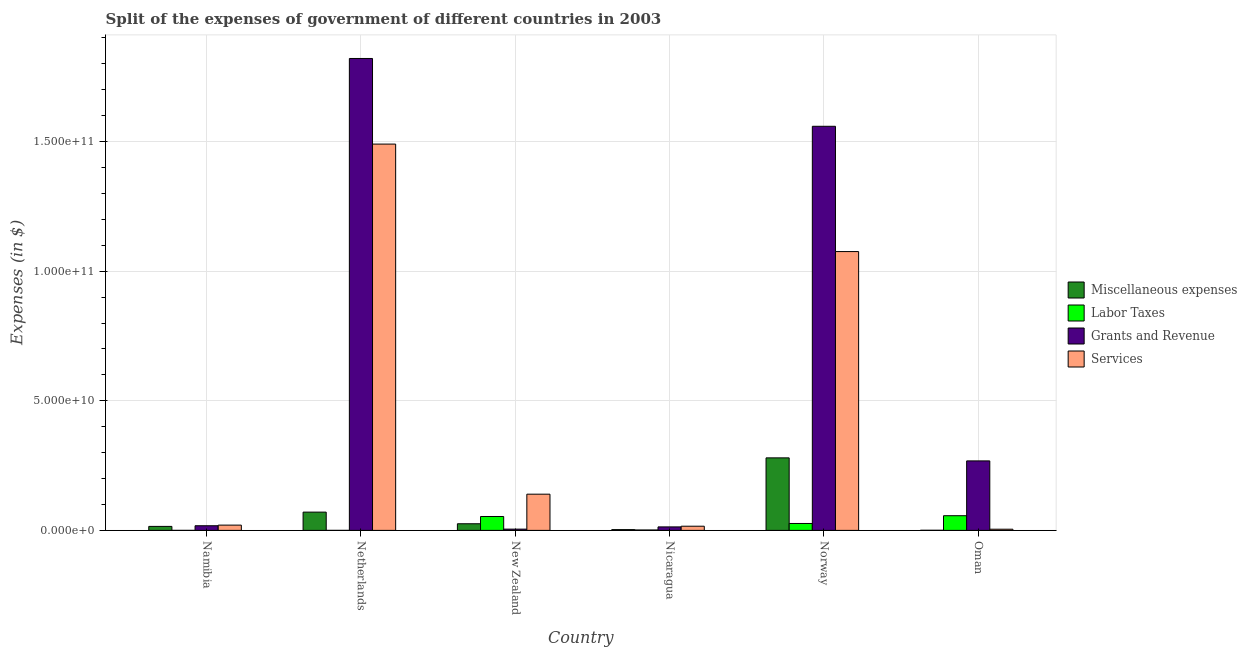How many different coloured bars are there?
Your answer should be compact. 4. Are the number of bars per tick equal to the number of legend labels?
Your answer should be very brief. No. Are the number of bars on each tick of the X-axis equal?
Provide a succinct answer. No. How many bars are there on the 4th tick from the right?
Provide a succinct answer. 4. In how many cases, is the number of bars for a given country not equal to the number of legend labels?
Make the answer very short. 1. What is the amount spent on services in New Zealand?
Make the answer very short. 1.40e+1. Across all countries, what is the maximum amount spent on labor taxes?
Keep it short and to the point. 5.66e+09. Across all countries, what is the minimum amount spent on labor taxes?
Your answer should be compact. 0. What is the total amount spent on miscellaneous expenses in the graph?
Offer a terse response. 3.95e+1. What is the difference between the amount spent on grants and revenue in Norway and that in Oman?
Keep it short and to the point. 1.29e+11. What is the difference between the amount spent on labor taxes in New Zealand and the amount spent on grants and revenue in Netherlands?
Provide a succinct answer. -1.77e+11. What is the average amount spent on grants and revenue per country?
Offer a terse response. 6.14e+1. What is the difference between the amount spent on grants and revenue and amount spent on miscellaneous expenses in Norway?
Keep it short and to the point. 1.28e+11. What is the ratio of the amount spent on services in Netherlands to that in New Zealand?
Provide a succinct answer. 10.67. Is the amount spent on services in Norway less than that in Oman?
Your response must be concise. No. What is the difference between the highest and the second highest amount spent on miscellaneous expenses?
Make the answer very short. 2.09e+1. What is the difference between the highest and the lowest amount spent on grants and revenue?
Ensure brevity in your answer.  1.82e+11. In how many countries, is the amount spent on miscellaneous expenses greater than the average amount spent on miscellaneous expenses taken over all countries?
Ensure brevity in your answer.  2. Is the sum of the amount spent on labor taxes in Netherlands and Norway greater than the maximum amount spent on miscellaneous expenses across all countries?
Your answer should be compact. No. Is it the case that in every country, the sum of the amount spent on miscellaneous expenses and amount spent on services is greater than the sum of amount spent on grants and revenue and amount spent on labor taxes?
Ensure brevity in your answer.  No. Is it the case that in every country, the sum of the amount spent on miscellaneous expenses and amount spent on labor taxes is greater than the amount spent on grants and revenue?
Your answer should be compact. No. How many bars are there?
Make the answer very short. 23. How many countries are there in the graph?
Ensure brevity in your answer.  6. What is the difference between two consecutive major ticks on the Y-axis?
Give a very brief answer. 5.00e+1. How many legend labels are there?
Provide a succinct answer. 4. How are the legend labels stacked?
Give a very brief answer. Vertical. What is the title of the graph?
Offer a terse response. Split of the expenses of government of different countries in 2003. Does "Tertiary education" appear as one of the legend labels in the graph?
Your response must be concise. No. What is the label or title of the Y-axis?
Offer a very short reply. Expenses (in $). What is the Expenses (in $) of Miscellaneous expenses in Namibia?
Make the answer very short. 1.54e+09. What is the Expenses (in $) of Labor Taxes in Namibia?
Provide a succinct answer. 0. What is the Expenses (in $) of Grants and Revenue in Namibia?
Your response must be concise. 1.79e+09. What is the Expenses (in $) in Services in Namibia?
Provide a succinct answer. 2.03e+09. What is the Expenses (in $) in Miscellaneous expenses in Netherlands?
Provide a succinct answer. 7.05e+09. What is the Expenses (in $) in Labor Taxes in Netherlands?
Your answer should be very brief. 2.05e+05. What is the Expenses (in $) of Grants and Revenue in Netherlands?
Offer a terse response. 1.82e+11. What is the Expenses (in $) in Services in Netherlands?
Your response must be concise. 1.49e+11. What is the Expenses (in $) in Miscellaneous expenses in New Zealand?
Provide a short and direct response. 2.56e+09. What is the Expenses (in $) in Labor Taxes in New Zealand?
Keep it short and to the point. 5.36e+09. What is the Expenses (in $) in Grants and Revenue in New Zealand?
Give a very brief answer. 4.88e+08. What is the Expenses (in $) in Services in New Zealand?
Keep it short and to the point. 1.40e+1. What is the Expenses (in $) of Miscellaneous expenses in Nicaragua?
Offer a very short reply. 3.00e+08. What is the Expenses (in $) in Labor Taxes in Nicaragua?
Offer a terse response. 1.58e+08. What is the Expenses (in $) of Grants and Revenue in Nicaragua?
Your answer should be very brief. 1.35e+09. What is the Expenses (in $) in Services in Nicaragua?
Provide a succinct answer. 1.61e+09. What is the Expenses (in $) in Miscellaneous expenses in Norway?
Provide a short and direct response. 2.80e+1. What is the Expenses (in $) in Labor Taxes in Norway?
Provide a short and direct response. 2.67e+09. What is the Expenses (in $) in Grants and Revenue in Norway?
Give a very brief answer. 1.56e+11. What is the Expenses (in $) in Services in Norway?
Make the answer very short. 1.08e+11. What is the Expenses (in $) of Miscellaneous expenses in Oman?
Your answer should be compact. 4.27e+07. What is the Expenses (in $) of Labor Taxes in Oman?
Your answer should be compact. 5.66e+09. What is the Expenses (in $) in Grants and Revenue in Oman?
Offer a very short reply. 2.68e+1. What is the Expenses (in $) of Services in Oman?
Make the answer very short. 4.55e+08. Across all countries, what is the maximum Expenses (in $) in Miscellaneous expenses?
Ensure brevity in your answer.  2.80e+1. Across all countries, what is the maximum Expenses (in $) in Labor Taxes?
Keep it short and to the point. 5.66e+09. Across all countries, what is the maximum Expenses (in $) in Grants and Revenue?
Give a very brief answer. 1.82e+11. Across all countries, what is the maximum Expenses (in $) in Services?
Provide a short and direct response. 1.49e+11. Across all countries, what is the minimum Expenses (in $) in Miscellaneous expenses?
Provide a succinct answer. 4.27e+07. Across all countries, what is the minimum Expenses (in $) in Grants and Revenue?
Provide a succinct answer. 4.88e+08. Across all countries, what is the minimum Expenses (in $) of Services?
Keep it short and to the point. 4.55e+08. What is the total Expenses (in $) of Miscellaneous expenses in the graph?
Provide a short and direct response. 3.95e+1. What is the total Expenses (in $) in Labor Taxes in the graph?
Your response must be concise. 1.39e+1. What is the total Expenses (in $) in Grants and Revenue in the graph?
Make the answer very short. 3.68e+11. What is the total Expenses (in $) in Services in the graph?
Provide a succinct answer. 2.75e+11. What is the difference between the Expenses (in $) of Miscellaneous expenses in Namibia and that in Netherlands?
Provide a succinct answer. -5.51e+09. What is the difference between the Expenses (in $) of Grants and Revenue in Namibia and that in Netherlands?
Your answer should be compact. -1.80e+11. What is the difference between the Expenses (in $) of Services in Namibia and that in Netherlands?
Provide a short and direct response. -1.47e+11. What is the difference between the Expenses (in $) in Miscellaneous expenses in Namibia and that in New Zealand?
Give a very brief answer. -1.02e+09. What is the difference between the Expenses (in $) of Grants and Revenue in Namibia and that in New Zealand?
Give a very brief answer. 1.30e+09. What is the difference between the Expenses (in $) in Services in Namibia and that in New Zealand?
Give a very brief answer. -1.19e+1. What is the difference between the Expenses (in $) of Miscellaneous expenses in Namibia and that in Nicaragua?
Provide a succinct answer. 1.24e+09. What is the difference between the Expenses (in $) of Grants and Revenue in Namibia and that in Nicaragua?
Ensure brevity in your answer.  4.46e+08. What is the difference between the Expenses (in $) of Services in Namibia and that in Nicaragua?
Keep it short and to the point. 4.21e+08. What is the difference between the Expenses (in $) of Miscellaneous expenses in Namibia and that in Norway?
Make the answer very short. -2.64e+1. What is the difference between the Expenses (in $) in Grants and Revenue in Namibia and that in Norway?
Your answer should be compact. -1.54e+11. What is the difference between the Expenses (in $) of Services in Namibia and that in Norway?
Ensure brevity in your answer.  -1.06e+11. What is the difference between the Expenses (in $) in Miscellaneous expenses in Namibia and that in Oman?
Ensure brevity in your answer.  1.50e+09. What is the difference between the Expenses (in $) of Grants and Revenue in Namibia and that in Oman?
Make the answer very short. -2.50e+1. What is the difference between the Expenses (in $) of Services in Namibia and that in Oman?
Keep it short and to the point. 1.58e+09. What is the difference between the Expenses (in $) of Miscellaneous expenses in Netherlands and that in New Zealand?
Keep it short and to the point. 4.49e+09. What is the difference between the Expenses (in $) in Labor Taxes in Netherlands and that in New Zealand?
Your answer should be very brief. -5.36e+09. What is the difference between the Expenses (in $) in Grants and Revenue in Netherlands and that in New Zealand?
Keep it short and to the point. 1.82e+11. What is the difference between the Expenses (in $) of Services in Netherlands and that in New Zealand?
Give a very brief answer. 1.35e+11. What is the difference between the Expenses (in $) in Miscellaneous expenses in Netherlands and that in Nicaragua?
Your answer should be compact. 6.75e+09. What is the difference between the Expenses (in $) of Labor Taxes in Netherlands and that in Nicaragua?
Make the answer very short. -1.58e+08. What is the difference between the Expenses (in $) of Grants and Revenue in Netherlands and that in Nicaragua?
Offer a very short reply. 1.81e+11. What is the difference between the Expenses (in $) of Services in Netherlands and that in Nicaragua?
Offer a very short reply. 1.47e+11. What is the difference between the Expenses (in $) in Miscellaneous expenses in Netherlands and that in Norway?
Ensure brevity in your answer.  -2.09e+1. What is the difference between the Expenses (in $) of Labor Taxes in Netherlands and that in Norway?
Keep it short and to the point. -2.67e+09. What is the difference between the Expenses (in $) in Grants and Revenue in Netherlands and that in Norway?
Offer a very short reply. 2.62e+1. What is the difference between the Expenses (in $) in Services in Netherlands and that in Norway?
Give a very brief answer. 4.15e+1. What is the difference between the Expenses (in $) of Miscellaneous expenses in Netherlands and that in Oman?
Offer a terse response. 7.00e+09. What is the difference between the Expenses (in $) in Labor Taxes in Netherlands and that in Oman?
Your answer should be compact. -5.66e+09. What is the difference between the Expenses (in $) of Grants and Revenue in Netherlands and that in Oman?
Your answer should be very brief. 1.55e+11. What is the difference between the Expenses (in $) of Services in Netherlands and that in Oman?
Ensure brevity in your answer.  1.49e+11. What is the difference between the Expenses (in $) in Miscellaneous expenses in New Zealand and that in Nicaragua?
Offer a terse response. 2.26e+09. What is the difference between the Expenses (in $) of Labor Taxes in New Zealand and that in Nicaragua?
Your answer should be compact. 5.21e+09. What is the difference between the Expenses (in $) in Grants and Revenue in New Zealand and that in Nicaragua?
Provide a short and direct response. -8.58e+08. What is the difference between the Expenses (in $) of Services in New Zealand and that in Nicaragua?
Provide a short and direct response. 1.24e+1. What is the difference between the Expenses (in $) in Miscellaneous expenses in New Zealand and that in Norway?
Ensure brevity in your answer.  -2.54e+1. What is the difference between the Expenses (in $) in Labor Taxes in New Zealand and that in Norway?
Keep it short and to the point. 2.70e+09. What is the difference between the Expenses (in $) in Grants and Revenue in New Zealand and that in Norway?
Keep it short and to the point. -1.55e+11. What is the difference between the Expenses (in $) of Services in New Zealand and that in Norway?
Provide a succinct answer. -9.36e+1. What is the difference between the Expenses (in $) in Miscellaneous expenses in New Zealand and that in Oman?
Ensure brevity in your answer.  2.52e+09. What is the difference between the Expenses (in $) of Labor Taxes in New Zealand and that in Oman?
Your response must be concise. -2.97e+08. What is the difference between the Expenses (in $) in Grants and Revenue in New Zealand and that in Oman?
Make the answer very short. -2.63e+1. What is the difference between the Expenses (in $) of Services in New Zealand and that in Oman?
Your answer should be compact. 1.35e+1. What is the difference between the Expenses (in $) of Miscellaneous expenses in Nicaragua and that in Norway?
Your answer should be compact. -2.77e+1. What is the difference between the Expenses (in $) in Labor Taxes in Nicaragua and that in Norway?
Make the answer very short. -2.51e+09. What is the difference between the Expenses (in $) of Grants and Revenue in Nicaragua and that in Norway?
Keep it short and to the point. -1.55e+11. What is the difference between the Expenses (in $) in Services in Nicaragua and that in Norway?
Provide a short and direct response. -1.06e+11. What is the difference between the Expenses (in $) in Miscellaneous expenses in Nicaragua and that in Oman?
Your response must be concise. 2.58e+08. What is the difference between the Expenses (in $) in Labor Taxes in Nicaragua and that in Oman?
Your answer should be very brief. -5.50e+09. What is the difference between the Expenses (in $) in Grants and Revenue in Nicaragua and that in Oman?
Make the answer very short. -2.55e+1. What is the difference between the Expenses (in $) of Services in Nicaragua and that in Oman?
Your answer should be very brief. 1.16e+09. What is the difference between the Expenses (in $) in Miscellaneous expenses in Norway and that in Oman?
Offer a very short reply. 2.79e+1. What is the difference between the Expenses (in $) of Labor Taxes in Norway and that in Oman?
Make the answer very short. -2.99e+09. What is the difference between the Expenses (in $) in Grants and Revenue in Norway and that in Oman?
Make the answer very short. 1.29e+11. What is the difference between the Expenses (in $) in Services in Norway and that in Oman?
Your answer should be very brief. 1.07e+11. What is the difference between the Expenses (in $) in Miscellaneous expenses in Namibia and the Expenses (in $) in Labor Taxes in Netherlands?
Offer a terse response. 1.54e+09. What is the difference between the Expenses (in $) of Miscellaneous expenses in Namibia and the Expenses (in $) of Grants and Revenue in Netherlands?
Provide a short and direct response. -1.81e+11. What is the difference between the Expenses (in $) of Miscellaneous expenses in Namibia and the Expenses (in $) of Services in Netherlands?
Keep it short and to the point. -1.48e+11. What is the difference between the Expenses (in $) in Grants and Revenue in Namibia and the Expenses (in $) in Services in Netherlands?
Keep it short and to the point. -1.47e+11. What is the difference between the Expenses (in $) of Miscellaneous expenses in Namibia and the Expenses (in $) of Labor Taxes in New Zealand?
Offer a terse response. -3.82e+09. What is the difference between the Expenses (in $) in Miscellaneous expenses in Namibia and the Expenses (in $) in Grants and Revenue in New Zealand?
Ensure brevity in your answer.  1.05e+09. What is the difference between the Expenses (in $) in Miscellaneous expenses in Namibia and the Expenses (in $) in Services in New Zealand?
Provide a succinct answer. -1.24e+1. What is the difference between the Expenses (in $) in Grants and Revenue in Namibia and the Expenses (in $) in Services in New Zealand?
Your response must be concise. -1.22e+1. What is the difference between the Expenses (in $) in Miscellaneous expenses in Namibia and the Expenses (in $) in Labor Taxes in Nicaragua?
Make the answer very short. 1.38e+09. What is the difference between the Expenses (in $) of Miscellaneous expenses in Namibia and the Expenses (in $) of Grants and Revenue in Nicaragua?
Offer a terse response. 1.96e+08. What is the difference between the Expenses (in $) in Miscellaneous expenses in Namibia and the Expenses (in $) in Services in Nicaragua?
Give a very brief answer. -6.87e+07. What is the difference between the Expenses (in $) of Grants and Revenue in Namibia and the Expenses (in $) of Services in Nicaragua?
Ensure brevity in your answer.  1.81e+08. What is the difference between the Expenses (in $) of Miscellaneous expenses in Namibia and the Expenses (in $) of Labor Taxes in Norway?
Make the answer very short. -1.13e+09. What is the difference between the Expenses (in $) of Miscellaneous expenses in Namibia and the Expenses (in $) of Grants and Revenue in Norway?
Provide a succinct answer. -1.54e+11. What is the difference between the Expenses (in $) in Miscellaneous expenses in Namibia and the Expenses (in $) in Services in Norway?
Give a very brief answer. -1.06e+11. What is the difference between the Expenses (in $) of Grants and Revenue in Namibia and the Expenses (in $) of Services in Norway?
Provide a short and direct response. -1.06e+11. What is the difference between the Expenses (in $) of Miscellaneous expenses in Namibia and the Expenses (in $) of Labor Taxes in Oman?
Offer a terse response. -4.12e+09. What is the difference between the Expenses (in $) in Miscellaneous expenses in Namibia and the Expenses (in $) in Grants and Revenue in Oman?
Offer a very short reply. -2.53e+1. What is the difference between the Expenses (in $) of Miscellaneous expenses in Namibia and the Expenses (in $) of Services in Oman?
Make the answer very short. 1.09e+09. What is the difference between the Expenses (in $) in Grants and Revenue in Namibia and the Expenses (in $) in Services in Oman?
Give a very brief answer. 1.34e+09. What is the difference between the Expenses (in $) of Miscellaneous expenses in Netherlands and the Expenses (in $) of Labor Taxes in New Zealand?
Your answer should be compact. 1.68e+09. What is the difference between the Expenses (in $) of Miscellaneous expenses in Netherlands and the Expenses (in $) of Grants and Revenue in New Zealand?
Provide a succinct answer. 6.56e+09. What is the difference between the Expenses (in $) in Miscellaneous expenses in Netherlands and the Expenses (in $) in Services in New Zealand?
Provide a succinct answer. -6.92e+09. What is the difference between the Expenses (in $) in Labor Taxes in Netherlands and the Expenses (in $) in Grants and Revenue in New Zealand?
Give a very brief answer. -4.88e+08. What is the difference between the Expenses (in $) in Labor Taxes in Netherlands and the Expenses (in $) in Services in New Zealand?
Make the answer very short. -1.40e+1. What is the difference between the Expenses (in $) of Grants and Revenue in Netherlands and the Expenses (in $) of Services in New Zealand?
Provide a succinct answer. 1.68e+11. What is the difference between the Expenses (in $) of Miscellaneous expenses in Netherlands and the Expenses (in $) of Labor Taxes in Nicaragua?
Your answer should be very brief. 6.89e+09. What is the difference between the Expenses (in $) in Miscellaneous expenses in Netherlands and the Expenses (in $) in Grants and Revenue in Nicaragua?
Make the answer very short. 5.70e+09. What is the difference between the Expenses (in $) in Miscellaneous expenses in Netherlands and the Expenses (in $) in Services in Nicaragua?
Give a very brief answer. 5.44e+09. What is the difference between the Expenses (in $) in Labor Taxes in Netherlands and the Expenses (in $) in Grants and Revenue in Nicaragua?
Provide a short and direct response. -1.35e+09. What is the difference between the Expenses (in $) in Labor Taxes in Netherlands and the Expenses (in $) in Services in Nicaragua?
Offer a very short reply. -1.61e+09. What is the difference between the Expenses (in $) in Grants and Revenue in Netherlands and the Expenses (in $) in Services in Nicaragua?
Give a very brief answer. 1.80e+11. What is the difference between the Expenses (in $) in Miscellaneous expenses in Netherlands and the Expenses (in $) in Labor Taxes in Norway?
Offer a terse response. 4.38e+09. What is the difference between the Expenses (in $) of Miscellaneous expenses in Netherlands and the Expenses (in $) of Grants and Revenue in Norway?
Provide a succinct answer. -1.49e+11. What is the difference between the Expenses (in $) in Miscellaneous expenses in Netherlands and the Expenses (in $) in Services in Norway?
Offer a terse response. -1.01e+11. What is the difference between the Expenses (in $) in Labor Taxes in Netherlands and the Expenses (in $) in Grants and Revenue in Norway?
Your response must be concise. -1.56e+11. What is the difference between the Expenses (in $) in Labor Taxes in Netherlands and the Expenses (in $) in Services in Norway?
Make the answer very short. -1.08e+11. What is the difference between the Expenses (in $) in Grants and Revenue in Netherlands and the Expenses (in $) in Services in Norway?
Keep it short and to the point. 7.45e+1. What is the difference between the Expenses (in $) in Miscellaneous expenses in Netherlands and the Expenses (in $) in Labor Taxes in Oman?
Offer a very short reply. 1.39e+09. What is the difference between the Expenses (in $) of Miscellaneous expenses in Netherlands and the Expenses (in $) of Grants and Revenue in Oman?
Provide a short and direct response. -1.98e+1. What is the difference between the Expenses (in $) in Miscellaneous expenses in Netherlands and the Expenses (in $) in Services in Oman?
Your response must be concise. 6.59e+09. What is the difference between the Expenses (in $) of Labor Taxes in Netherlands and the Expenses (in $) of Grants and Revenue in Oman?
Your answer should be very brief. -2.68e+1. What is the difference between the Expenses (in $) of Labor Taxes in Netherlands and the Expenses (in $) of Services in Oman?
Provide a succinct answer. -4.54e+08. What is the difference between the Expenses (in $) of Grants and Revenue in Netherlands and the Expenses (in $) of Services in Oman?
Ensure brevity in your answer.  1.82e+11. What is the difference between the Expenses (in $) in Miscellaneous expenses in New Zealand and the Expenses (in $) in Labor Taxes in Nicaragua?
Your answer should be compact. 2.40e+09. What is the difference between the Expenses (in $) of Miscellaneous expenses in New Zealand and the Expenses (in $) of Grants and Revenue in Nicaragua?
Your answer should be compact. 1.21e+09. What is the difference between the Expenses (in $) of Miscellaneous expenses in New Zealand and the Expenses (in $) of Services in Nicaragua?
Your answer should be compact. 9.48e+08. What is the difference between the Expenses (in $) in Labor Taxes in New Zealand and the Expenses (in $) in Grants and Revenue in Nicaragua?
Provide a short and direct response. 4.02e+09. What is the difference between the Expenses (in $) in Labor Taxes in New Zealand and the Expenses (in $) in Services in Nicaragua?
Your answer should be very brief. 3.75e+09. What is the difference between the Expenses (in $) in Grants and Revenue in New Zealand and the Expenses (in $) in Services in Nicaragua?
Give a very brief answer. -1.12e+09. What is the difference between the Expenses (in $) in Miscellaneous expenses in New Zealand and the Expenses (in $) in Labor Taxes in Norway?
Provide a short and direct response. -1.09e+08. What is the difference between the Expenses (in $) in Miscellaneous expenses in New Zealand and the Expenses (in $) in Grants and Revenue in Norway?
Make the answer very short. -1.53e+11. What is the difference between the Expenses (in $) in Miscellaneous expenses in New Zealand and the Expenses (in $) in Services in Norway?
Make the answer very short. -1.05e+11. What is the difference between the Expenses (in $) of Labor Taxes in New Zealand and the Expenses (in $) of Grants and Revenue in Norway?
Offer a very short reply. -1.51e+11. What is the difference between the Expenses (in $) in Labor Taxes in New Zealand and the Expenses (in $) in Services in Norway?
Keep it short and to the point. -1.02e+11. What is the difference between the Expenses (in $) of Grants and Revenue in New Zealand and the Expenses (in $) of Services in Norway?
Your answer should be compact. -1.07e+11. What is the difference between the Expenses (in $) of Miscellaneous expenses in New Zealand and the Expenses (in $) of Labor Taxes in Oman?
Provide a short and direct response. -3.10e+09. What is the difference between the Expenses (in $) in Miscellaneous expenses in New Zealand and the Expenses (in $) in Grants and Revenue in Oman?
Offer a terse response. -2.43e+1. What is the difference between the Expenses (in $) of Miscellaneous expenses in New Zealand and the Expenses (in $) of Services in Oman?
Ensure brevity in your answer.  2.10e+09. What is the difference between the Expenses (in $) of Labor Taxes in New Zealand and the Expenses (in $) of Grants and Revenue in Oman?
Provide a succinct answer. -2.14e+1. What is the difference between the Expenses (in $) in Labor Taxes in New Zealand and the Expenses (in $) in Services in Oman?
Provide a succinct answer. 4.91e+09. What is the difference between the Expenses (in $) in Grants and Revenue in New Zealand and the Expenses (in $) in Services in Oman?
Provide a succinct answer. 3.32e+07. What is the difference between the Expenses (in $) of Miscellaneous expenses in Nicaragua and the Expenses (in $) of Labor Taxes in Norway?
Your response must be concise. -2.37e+09. What is the difference between the Expenses (in $) in Miscellaneous expenses in Nicaragua and the Expenses (in $) in Grants and Revenue in Norway?
Make the answer very short. -1.56e+11. What is the difference between the Expenses (in $) of Miscellaneous expenses in Nicaragua and the Expenses (in $) of Services in Norway?
Offer a terse response. -1.07e+11. What is the difference between the Expenses (in $) of Labor Taxes in Nicaragua and the Expenses (in $) of Grants and Revenue in Norway?
Offer a terse response. -1.56e+11. What is the difference between the Expenses (in $) of Labor Taxes in Nicaragua and the Expenses (in $) of Services in Norway?
Offer a terse response. -1.07e+11. What is the difference between the Expenses (in $) of Grants and Revenue in Nicaragua and the Expenses (in $) of Services in Norway?
Provide a succinct answer. -1.06e+11. What is the difference between the Expenses (in $) in Miscellaneous expenses in Nicaragua and the Expenses (in $) in Labor Taxes in Oman?
Your answer should be very brief. -5.36e+09. What is the difference between the Expenses (in $) in Miscellaneous expenses in Nicaragua and the Expenses (in $) in Grants and Revenue in Oman?
Provide a short and direct response. -2.65e+1. What is the difference between the Expenses (in $) in Miscellaneous expenses in Nicaragua and the Expenses (in $) in Services in Oman?
Keep it short and to the point. -1.54e+08. What is the difference between the Expenses (in $) of Labor Taxes in Nicaragua and the Expenses (in $) of Grants and Revenue in Oman?
Ensure brevity in your answer.  -2.67e+1. What is the difference between the Expenses (in $) of Labor Taxes in Nicaragua and the Expenses (in $) of Services in Oman?
Give a very brief answer. -2.97e+08. What is the difference between the Expenses (in $) in Grants and Revenue in Nicaragua and the Expenses (in $) in Services in Oman?
Provide a succinct answer. 8.91e+08. What is the difference between the Expenses (in $) of Miscellaneous expenses in Norway and the Expenses (in $) of Labor Taxes in Oman?
Make the answer very short. 2.23e+1. What is the difference between the Expenses (in $) of Miscellaneous expenses in Norway and the Expenses (in $) of Grants and Revenue in Oman?
Your answer should be compact. 1.17e+09. What is the difference between the Expenses (in $) of Miscellaneous expenses in Norway and the Expenses (in $) of Services in Oman?
Provide a succinct answer. 2.75e+1. What is the difference between the Expenses (in $) in Labor Taxes in Norway and the Expenses (in $) in Grants and Revenue in Oman?
Give a very brief answer. -2.41e+1. What is the difference between the Expenses (in $) in Labor Taxes in Norway and the Expenses (in $) in Services in Oman?
Offer a terse response. 2.21e+09. What is the difference between the Expenses (in $) in Grants and Revenue in Norway and the Expenses (in $) in Services in Oman?
Keep it short and to the point. 1.55e+11. What is the average Expenses (in $) in Miscellaneous expenses per country?
Your response must be concise. 6.58e+09. What is the average Expenses (in $) of Labor Taxes per country?
Keep it short and to the point. 2.31e+09. What is the average Expenses (in $) in Grants and Revenue per country?
Offer a very short reply. 6.14e+1. What is the average Expenses (in $) of Services per country?
Give a very brief answer. 4.58e+1. What is the difference between the Expenses (in $) of Miscellaneous expenses and Expenses (in $) of Grants and Revenue in Namibia?
Keep it short and to the point. -2.50e+08. What is the difference between the Expenses (in $) in Miscellaneous expenses and Expenses (in $) in Services in Namibia?
Your response must be concise. -4.90e+08. What is the difference between the Expenses (in $) in Grants and Revenue and Expenses (in $) in Services in Namibia?
Offer a terse response. -2.40e+08. What is the difference between the Expenses (in $) of Miscellaneous expenses and Expenses (in $) of Labor Taxes in Netherlands?
Keep it short and to the point. 7.05e+09. What is the difference between the Expenses (in $) in Miscellaneous expenses and Expenses (in $) in Grants and Revenue in Netherlands?
Keep it short and to the point. -1.75e+11. What is the difference between the Expenses (in $) of Miscellaneous expenses and Expenses (in $) of Services in Netherlands?
Your answer should be very brief. -1.42e+11. What is the difference between the Expenses (in $) in Labor Taxes and Expenses (in $) in Grants and Revenue in Netherlands?
Ensure brevity in your answer.  -1.82e+11. What is the difference between the Expenses (in $) of Labor Taxes and Expenses (in $) of Services in Netherlands?
Provide a short and direct response. -1.49e+11. What is the difference between the Expenses (in $) in Grants and Revenue and Expenses (in $) in Services in Netherlands?
Ensure brevity in your answer.  3.30e+1. What is the difference between the Expenses (in $) of Miscellaneous expenses and Expenses (in $) of Labor Taxes in New Zealand?
Ensure brevity in your answer.  -2.81e+09. What is the difference between the Expenses (in $) in Miscellaneous expenses and Expenses (in $) in Grants and Revenue in New Zealand?
Provide a short and direct response. 2.07e+09. What is the difference between the Expenses (in $) in Miscellaneous expenses and Expenses (in $) in Services in New Zealand?
Provide a succinct answer. -1.14e+1. What is the difference between the Expenses (in $) of Labor Taxes and Expenses (in $) of Grants and Revenue in New Zealand?
Keep it short and to the point. 4.88e+09. What is the difference between the Expenses (in $) in Labor Taxes and Expenses (in $) in Services in New Zealand?
Ensure brevity in your answer.  -8.60e+09. What is the difference between the Expenses (in $) of Grants and Revenue and Expenses (in $) of Services in New Zealand?
Make the answer very short. -1.35e+1. What is the difference between the Expenses (in $) in Miscellaneous expenses and Expenses (in $) in Labor Taxes in Nicaragua?
Provide a short and direct response. 1.43e+08. What is the difference between the Expenses (in $) in Miscellaneous expenses and Expenses (in $) in Grants and Revenue in Nicaragua?
Provide a short and direct response. -1.05e+09. What is the difference between the Expenses (in $) in Miscellaneous expenses and Expenses (in $) in Services in Nicaragua?
Your answer should be compact. -1.31e+09. What is the difference between the Expenses (in $) of Labor Taxes and Expenses (in $) of Grants and Revenue in Nicaragua?
Your answer should be very brief. -1.19e+09. What is the difference between the Expenses (in $) in Labor Taxes and Expenses (in $) in Services in Nicaragua?
Keep it short and to the point. -1.45e+09. What is the difference between the Expenses (in $) in Grants and Revenue and Expenses (in $) in Services in Nicaragua?
Provide a succinct answer. -2.64e+08. What is the difference between the Expenses (in $) in Miscellaneous expenses and Expenses (in $) in Labor Taxes in Norway?
Provide a short and direct response. 2.53e+1. What is the difference between the Expenses (in $) in Miscellaneous expenses and Expenses (in $) in Grants and Revenue in Norway?
Your response must be concise. -1.28e+11. What is the difference between the Expenses (in $) of Miscellaneous expenses and Expenses (in $) of Services in Norway?
Your response must be concise. -7.96e+1. What is the difference between the Expenses (in $) of Labor Taxes and Expenses (in $) of Grants and Revenue in Norway?
Ensure brevity in your answer.  -1.53e+11. What is the difference between the Expenses (in $) of Labor Taxes and Expenses (in $) of Services in Norway?
Ensure brevity in your answer.  -1.05e+11. What is the difference between the Expenses (in $) in Grants and Revenue and Expenses (in $) in Services in Norway?
Give a very brief answer. 4.83e+1. What is the difference between the Expenses (in $) of Miscellaneous expenses and Expenses (in $) of Labor Taxes in Oman?
Keep it short and to the point. -5.62e+09. What is the difference between the Expenses (in $) of Miscellaneous expenses and Expenses (in $) of Grants and Revenue in Oman?
Give a very brief answer. -2.68e+1. What is the difference between the Expenses (in $) in Miscellaneous expenses and Expenses (in $) in Services in Oman?
Provide a short and direct response. -4.12e+08. What is the difference between the Expenses (in $) of Labor Taxes and Expenses (in $) of Grants and Revenue in Oman?
Offer a terse response. -2.12e+1. What is the difference between the Expenses (in $) of Labor Taxes and Expenses (in $) of Services in Oman?
Make the answer very short. 5.21e+09. What is the difference between the Expenses (in $) of Grants and Revenue and Expenses (in $) of Services in Oman?
Provide a succinct answer. 2.64e+1. What is the ratio of the Expenses (in $) in Miscellaneous expenses in Namibia to that in Netherlands?
Keep it short and to the point. 0.22. What is the ratio of the Expenses (in $) in Grants and Revenue in Namibia to that in Netherlands?
Offer a terse response. 0.01. What is the ratio of the Expenses (in $) of Services in Namibia to that in Netherlands?
Offer a very short reply. 0.01. What is the ratio of the Expenses (in $) in Miscellaneous expenses in Namibia to that in New Zealand?
Ensure brevity in your answer.  0.6. What is the ratio of the Expenses (in $) of Grants and Revenue in Namibia to that in New Zealand?
Your response must be concise. 3.67. What is the ratio of the Expenses (in $) of Services in Namibia to that in New Zealand?
Keep it short and to the point. 0.15. What is the ratio of the Expenses (in $) of Miscellaneous expenses in Namibia to that in Nicaragua?
Your response must be concise. 5.13. What is the ratio of the Expenses (in $) in Grants and Revenue in Namibia to that in Nicaragua?
Give a very brief answer. 1.33. What is the ratio of the Expenses (in $) in Services in Namibia to that in Nicaragua?
Provide a short and direct response. 1.26. What is the ratio of the Expenses (in $) in Miscellaneous expenses in Namibia to that in Norway?
Your answer should be compact. 0.06. What is the ratio of the Expenses (in $) of Grants and Revenue in Namibia to that in Norway?
Give a very brief answer. 0.01. What is the ratio of the Expenses (in $) of Services in Namibia to that in Norway?
Your response must be concise. 0.02. What is the ratio of the Expenses (in $) in Miscellaneous expenses in Namibia to that in Oman?
Offer a very short reply. 36.11. What is the ratio of the Expenses (in $) in Grants and Revenue in Namibia to that in Oman?
Ensure brevity in your answer.  0.07. What is the ratio of the Expenses (in $) in Services in Namibia to that in Oman?
Provide a succinct answer. 4.47. What is the ratio of the Expenses (in $) of Miscellaneous expenses in Netherlands to that in New Zealand?
Your answer should be very brief. 2.75. What is the ratio of the Expenses (in $) in Labor Taxes in Netherlands to that in New Zealand?
Offer a terse response. 0. What is the ratio of the Expenses (in $) in Grants and Revenue in Netherlands to that in New Zealand?
Keep it short and to the point. 373.18. What is the ratio of the Expenses (in $) in Services in Netherlands to that in New Zealand?
Your answer should be very brief. 10.67. What is the ratio of the Expenses (in $) of Miscellaneous expenses in Netherlands to that in Nicaragua?
Offer a terse response. 23.45. What is the ratio of the Expenses (in $) in Labor Taxes in Netherlands to that in Nicaragua?
Give a very brief answer. 0. What is the ratio of the Expenses (in $) of Grants and Revenue in Netherlands to that in Nicaragua?
Provide a succinct answer. 135.26. What is the ratio of the Expenses (in $) in Services in Netherlands to that in Nicaragua?
Keep it short and to the point. 92.54. What is the ratio of the Expenses (in $) of Miscellaneous expenses in Netherlands to that in Norway?
Make the answer very short. 0.25. What is the ratio of the Expenses (in $) of Grants and Revenue in Netherlands to that in Norway?
Offer a terse response. 1.17. What is the ratio of the Expenses (in $) in Services in Netherlands to that in Norway?
Offer a terse response. 1.39. What is the ratio of the Expenses (in $) in Miscellaneous expenses in Netherlands to that in Oman?
Offer a terse response. 165.04. What is the ratio of the Expenses (in $) of Labor Taxes in Netherlands to that in Oman?
Make the answer very short. 0. What is the ratio of the Expenses (in $) of Grants and Revenue in Netherlands to that in Oman?
Keep it short and to the point. 6.79. What is the ratio of the Expenses (in $) of Services in Netherlands to that in Oman?
Ensure brevity in your answer.  327.82. What is the ratio of the Expenses (in $) of Miscellaneous expenses in New Zealand to that in Nicaragua?
Make the answer very short. 8.51. What is the ratio of the Expenses (in $) of Labor Taxes in New Zealand to that in Nicaragua?
Your answer should be very brief. 33.96. What is the ratio of the Expenses (in $) of Grants and Revenue in New Zealand to that in Nicaragua?
Provide a short and direct response. 0.36. What is the ratio of the Expenses (in $) in Services in New Zealand to that in Nicaragua?
Offer a very short reply. 8.67. What is the ratio of the Expenses (in $) in Miscellaneous expenses in New Zealand to that in Norway?
Keep it short and to the point. 0.09. What is the ratio of the Expenses (in $) in Labor Taxes in New Zealand to that in Norway?
Your answer should be compact. 2.01. What is the ratio of the Expenses (in $) in Grants and Revenue in New Zealand to that in Norway?
Provide a succinct answer. 0. What is the ratio of the Expenses (in $) in Services in New Zealand to that in Norway?
Your answer should be very brief. 0.13. What is the ratio of the Expenses (in $) in Miscellaneous expenses in New Zealand to that in Oman?
Ensure brevity in your answer.  59.91. What is the ratio of the Expenses (in $) in Labor Taxes in New Zealand to that in Oman?
Give a very brief answer. 0.95. What is the ratio of the Expenses (in $) of Grants and Revenue in New Zealand to that in Oman?
Offer a very short reply. 0.02. What is the ratio of the Expenses (in $) of Services in New Zealand to that in Oman?
Your answer should be very brief. 30.72. What is the ratio of the Expenses (in $) in Miscellaneous expenses in Nicaragua to that in Norway?
Provide a short and direct response. 0.01. What is the ratio of the Expenses (in $) in Labor Taxes in Nicaragua to that in Norway?
Your answer should be compact. 0.06. What is the ratio of the Expenses (in $) of Grants and Revenue in Nicaragua to that in Norway?
Offer a terse response. 0.01. What is the ratio of the Expenses (in $) of Services in Nicaragua to that in Norway?
Ensure brevity in your answer.  0.01. What is the ratio of the Expenses (in $) of Miscellaneous expenses in Nicaragua to that in Oman?
Give a very brief answer. 7.04. What is the ratio of the Expenses (in $) in Labor Taxes in Nicaragua to that in Oman?
Keep it short and to the point. 0.03. What is the ratio of the Expenses (in $) in Grants and Revenue in Nicaragua to that in Oman?
Provide a succinct answer. 0.05. What is the ratio of the Expenses (in $) in Services in Nicaragua to that in Oman?
Your answer should be very brief. 3.54. What is the ratio of the Expenses (in $) in Miscellaneous expenses in Norway to that in Oman?
Offer a very short reply. 655.32. What is the ratio of the Expenses (in $) of Labor Taxes in Norway to that in Oman?
Give a very brief answer. 0.47. What is the ratio of the Expenses (in $) in Grants and Revenue in Norway to that in Oman?
Keep it short and to the point. 5.81. What is the ratio of the Expenses (in $) in Services in Norway to that in Oman?
Your answer should be compact. 236.6. What is the difference between the highest and the second highest Expenses (in $) in Miscellaneous expenses?
Provide a short and direct response. 2.09e+1. What is the difference between the highest and the second highest Expenses (in $) of Labor Taxes?
Provide a succinct answer. 2.97e+08. What is the difference between the highest and the second highest Expenses (in $) of Grants and Revenue?
Provide a short and direct response. 2.62e+1. What is the difference between the highest and the second highest Expenses (in $) in Services?
Your response must be concise. 4.15e+1. What is the difference between the highest and the lowest Expenses (in $) of Miscellaneous expenses?
Provide a short and direct response. 2.79e+1. What is the difference between the highest and the lowest Expenses (in $) in Labor Taxes?
Your answer should be very brief. 5.66e+09. What is the difference between the highest and the lowest Expenses (in $) in Grants and Revenue?
Your answer should be compact. 1.82e+11. What is the difference between the highest and the lowest Expenses (in $) in Services?
Provide a short and direct response. 1.49e+11. 